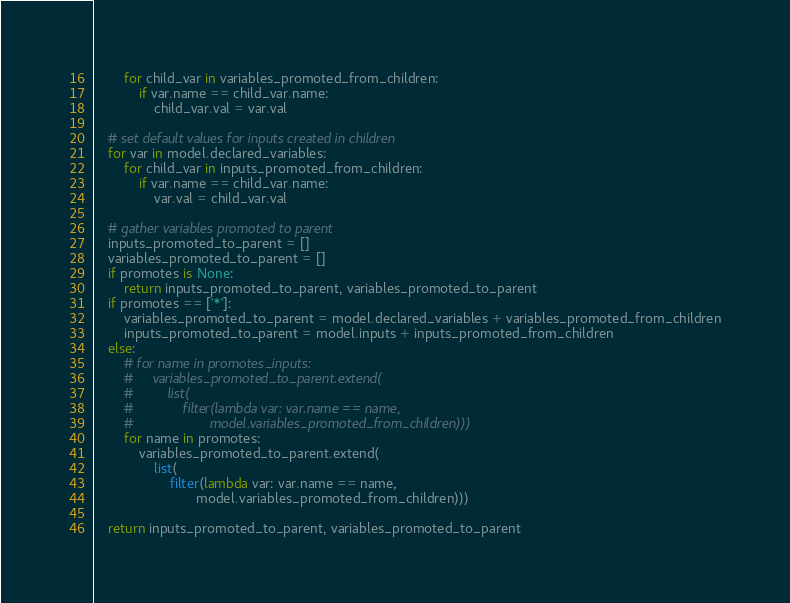Convert code to text. <code><loc_0><loc_0><loc_500><loc_500><_Python_>        for child_var in variables_promoted_from_children:
            if var.name == child_var.name:
                child_var.val = var.val

    # set default values for inputs created in children
    for var in model.declared_variables:
        for child_var in inputs_promoted_from_children:
            if var.name == child_var.name:
                var.val = child_var.val

    # gather variables promoted to parent
    inputs_promoted_to_parent = []
    variables_promoted_to_parent = []
    if promotes is None:
        return inputs_promoted_to_parent, variables_promoted_to_parent
    if promotes == ['*']:
        variables_promoted_to_parent = model.declared_variables + variables_promoted_from_children
        inputs_promoted_to_parent = model.inputs + inputs_promoted_from_children
    else:
        # for name in promotes_inputs:
        #     variables_promoted_to_parent.extend(
        #         list(
        #             filter(lambda var: var.name == name,
        #                    model.variables_promoted_from_children)))
        for name in promotes:
            variables_promoted_to_parent.extend(
                list(
                    filter(lambda var: var.name == name,
                           model.variables_promoted_from_children)))

    return inputs_promoted_to_parent, variables_promoted_to_parent
</code> 